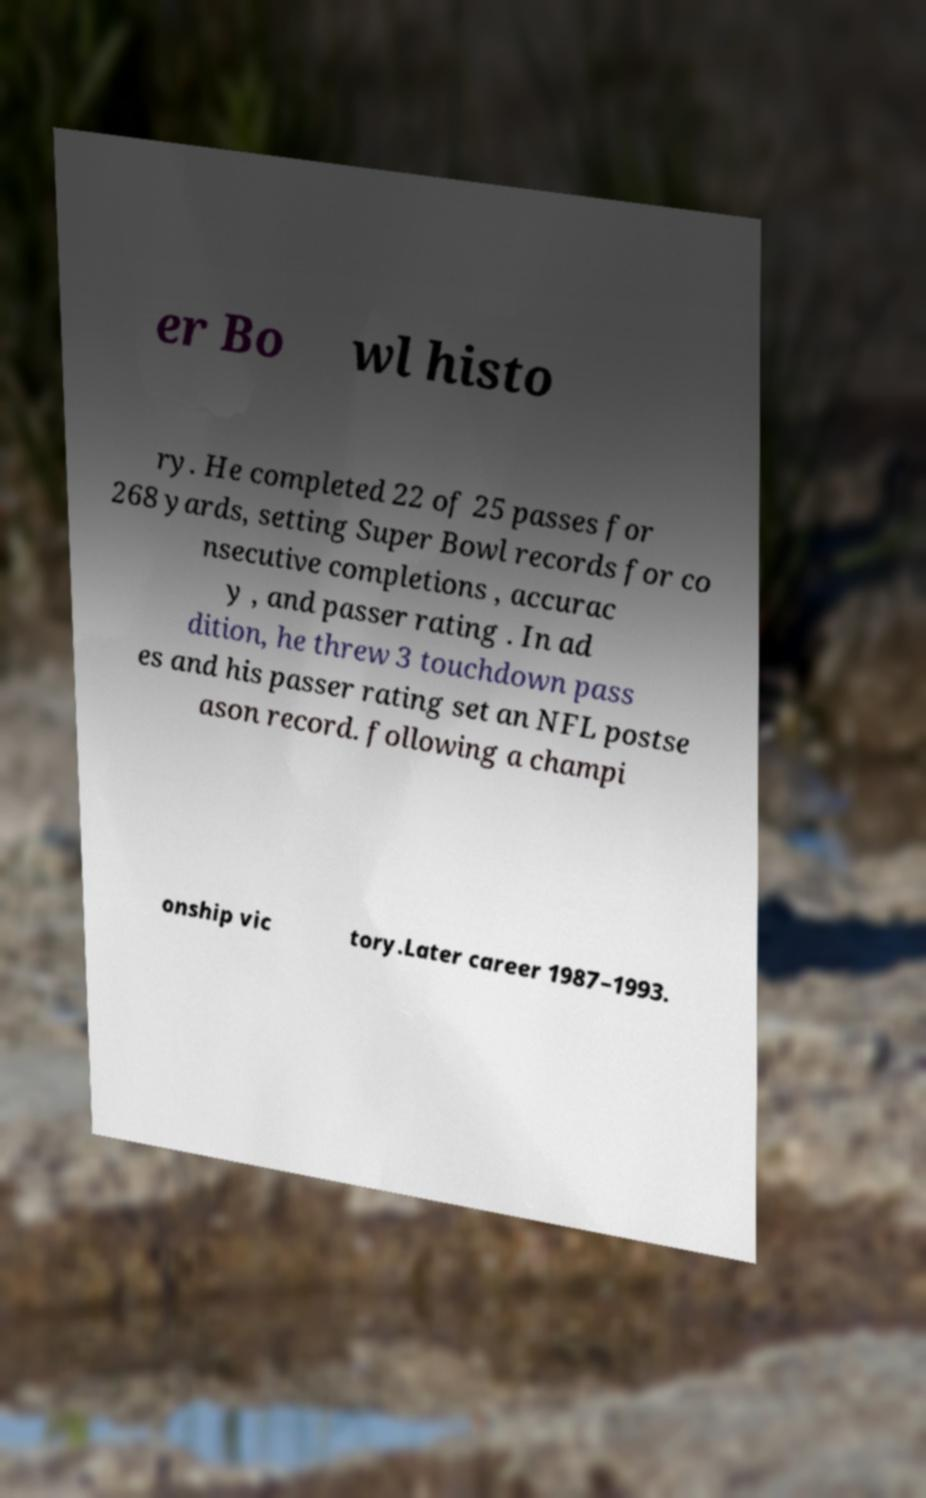Could you extract and type out the text from this image? er Bo wl histo ry. He completed 22 of 25 passes for 268 yards, setting Super Bowl records for co nsecutive completions , accurac y , and passer rating . In ad dition, he threw 3 touchdown pass es and his passer rating set an NFL postse ason record. following a champi onship vic tory.Later career 1987–1993. 